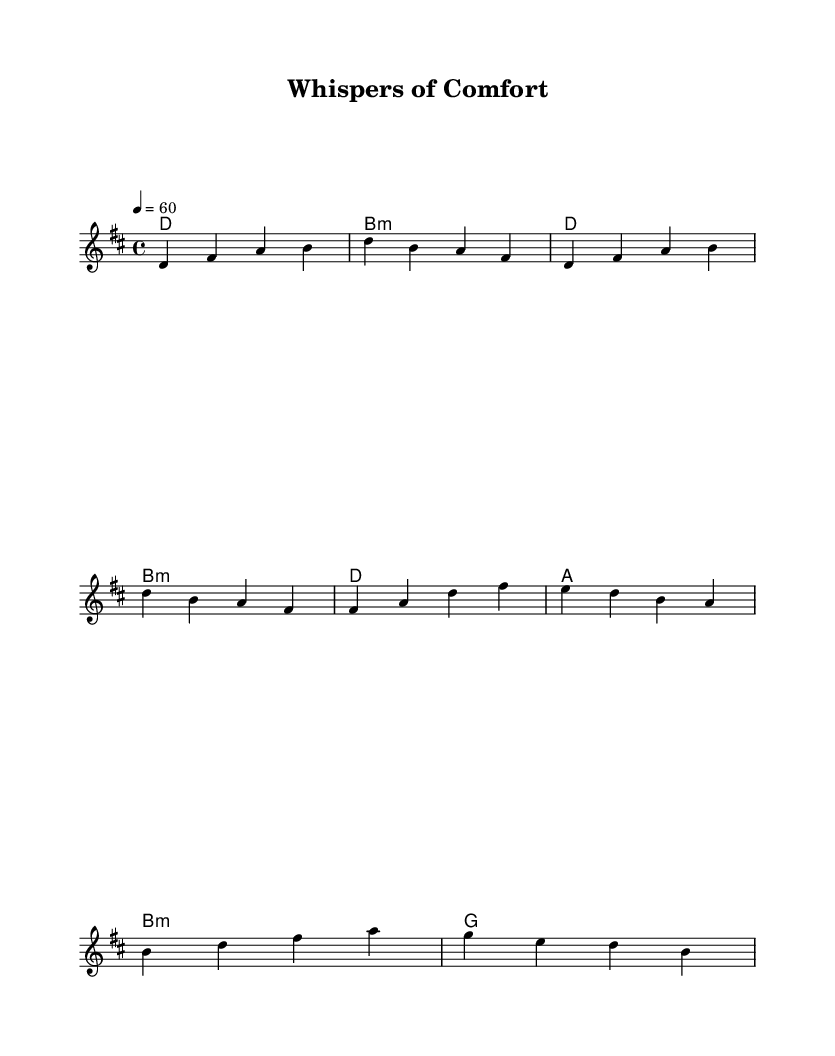What is the key signature of this music? The key signature is D major, which has two sharps (F# and C#).
Answer: D major What is the time signature of this piece? The time signature is 4/4, indicating four beats per measure.
Answer: 4/4 What is the tempo marking for this music? The tempo marking is quarter note equals 60 beats per minute, indicating a slow pace.
Answer: 60 What is the first chord used in the piece? The first chord in the score is D major, which is indicated at the start of the harmony section.
Answer: D How many measures are in the chorus section? The chorus section shown in the music contains two measures (the partial chorus).
Answer: 2 What is the last chord indicated before the bridge? The last chord indicated before the bridge is B minor. This is shown in the harmony section.
Answer: B minor What type of music fusion is represented by this piece? This piece represents an ambient-folk fusion, combining tranquil melodies with nature sounds for calming effects.
Answer: Ambient-folk fusion 